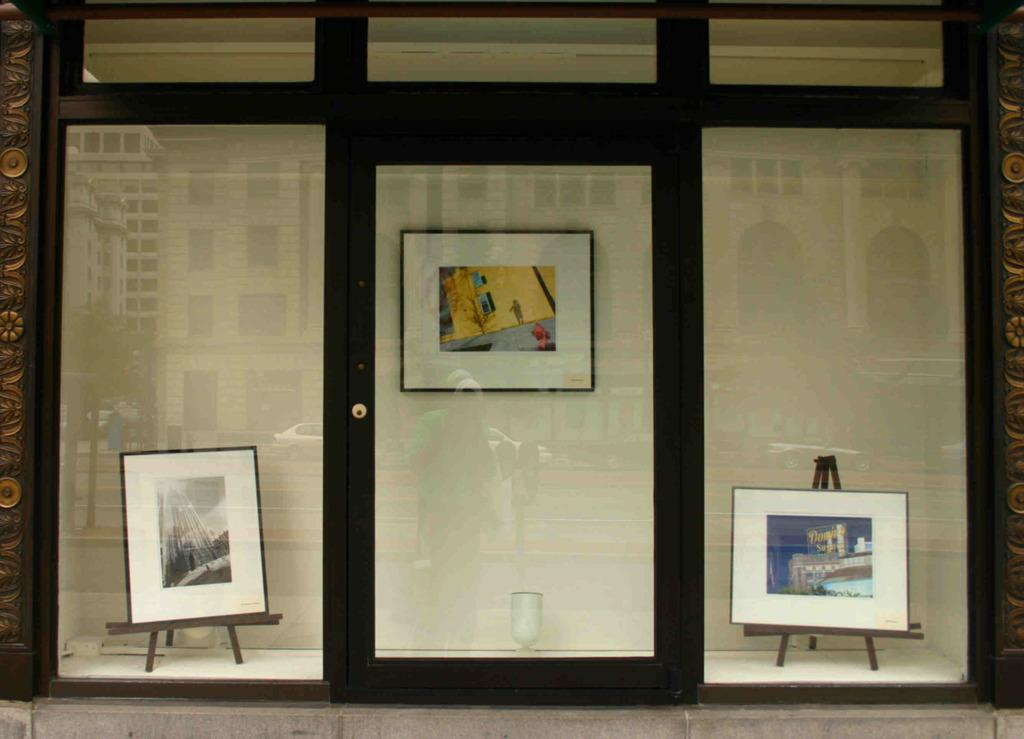What type of objects are used to display photos in the image? There are photo frames on stands and on the walls in the image. Can you describe the architectural features in the image? There is a glass door and a glass wall in the image. What type of crate is used to store the photo frames in the image? There is no crate present in the image; the photo frames are displayed on stands and on the walls. How are the stockings hung on the glass wall in the image? There are no stockings or hooks present in the image; it only features photo frames, a glass door, and a glass wall. 